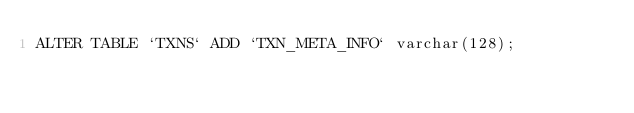Convert code to text. <code><loc_0><loc_0><loc_500><loc_500><_SQL_>ALTER TABLE `TXNS` ADD `TXN_META_INFO` varchar(128);
</code> 